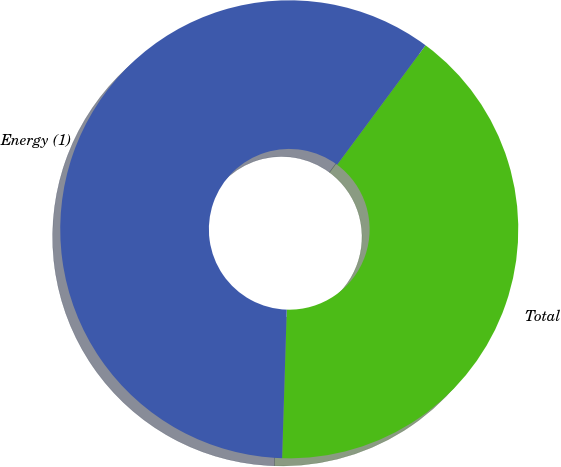Convert chart to OTSL. <chart><loc_0><loc_0><loc_500><loc_500><pie_chart><fcel>Total<fcel>Energy (1)<nl><fcel>40.35%<fcel>59.65%<nl></chart> 